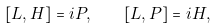<formula> <loc_0><loc_0><loc_500><loc_500>[ L , H ] = i P , \quad [ L , P ] = i H ,</formula> 